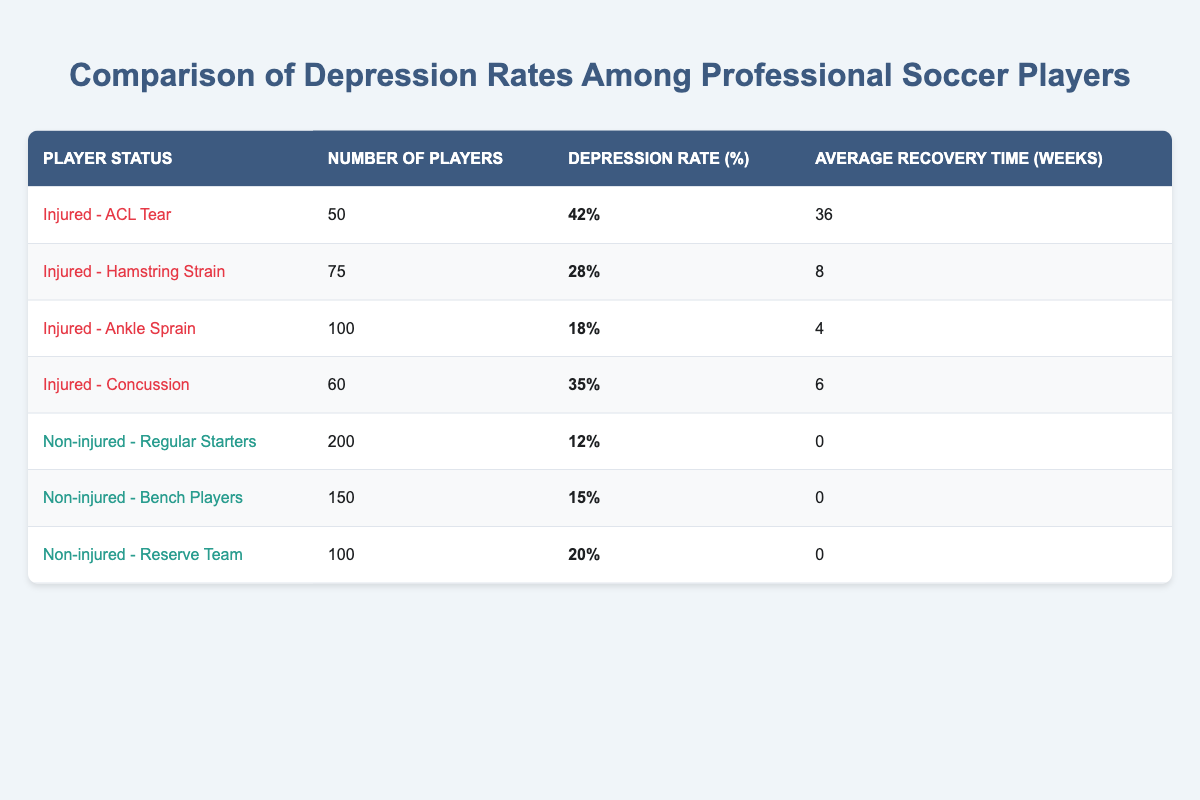What is the depression rate for injured players with an ACL tear? The table indicates that the depression rate for players injured with an ACL tear is listed directly in the row corresponding to "Injured - ACL Tear." According to the table, this rate is 42%.
Answer: 42% How many injured soccer players had a hamstring strain? Referring to the table, the row labeled "Injured - Hamstring Strain" shows that there are 75 players in this category.
Answer: 75 What is the average depression rate of non-injured players? To calculate the average depression rate for non-injured players, we will take the rates from the three categories: Regular Starters (12%), Bench Players (15%), and Reserve Team (20%). The sum is (12 + 15 + 20) = 47%, and then we divide by the number of categories (3), resulting in an average of 47/3 = approximately 15.67%.
Answer: Approximately 15.67% Is it true that bench players have a higher depression rate than players with ankle sprains? Checking the table, the depression rate for bench players is 15%, while the rate for ankle sprain players is 18%. Since 15% is less than 18%, the statement is false.
Answer: No Which category of injured players has the highest average recovery time, and what is that time? Looking at the average recovery times in the table, the "Injured - ACL Tear" category has an average recovery time of 36 weeks, which is the highest among the listed categories. All other injured categories have lower recovery times.
Answer: 36 weeks What is the difference in depression rates between injured players with a concussion and non-injured regular starters? The depression rate for injured players with a concussion is 35%, and for non-injured regular starters, it is 12%. To find the difference, we subtract 12% from 35%, yielding a difference of 23%.
Answer: 23% Among the injured players listed, which condition has the lowest depression rate and what is that rate? By examining the depression rates for the injured players: ACL Tear (42%), Hamstring Strain (28%), Ankle Sprain (18%), and Concussion (35%), it is clear that Ankle Sprain has the lowest rate at 18%.
Answer: 18% What percentage of the total players in the table are classified as non-injured? First, we sum the number of players in all categories: 50 (ACL) + 75 (Hamstring) + 100 (Ankle) + 60 (Concussion) + 200 (Starters) + 150 (Bench) + 100 (Reserves) = 735. Then, we calculate the non-injured players: 200 + 150 + 100 = 450. The percentage is (450/735) * 100, which is approximately 61.22%.
Answer: Approximately 61.22% 